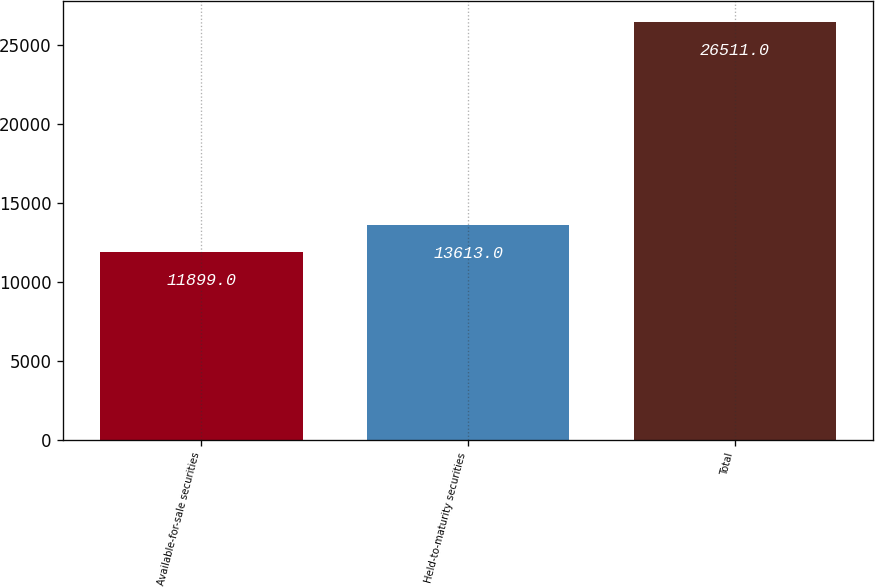<chart> <loc_0><loc_0><loc_500><loc_500><bar_chart><fcel>Available-for-sale securities<fcel>Held-to-maturity securities<fcel>Total<nl><fcel>11899<fcel>13613<fcel>26511<nl></chart> 